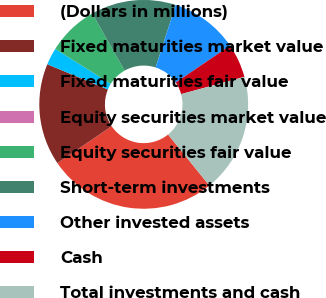<chart> <loc_0><loc_0><loc_500><loc_500><pie_chart><fcel>(Dollars in millions)<fcel>Fixed maturities market value<fcel>Fixed maturities fair value<fcel>Equity securities market value<fcel>Equity securities fair value<fcel>Short-term investments<fcel>Other invested assets<fcel>Cash<fcel>Total investments and cash<nl><fcel>26.31%<fcel>15.79%<fcel>2.63%<fcel>0.0%<fcel>7.9%<fcel>13.16%<fcel>10.53%<fcel>5.26%<fcel>18.42%<nl></chart> 